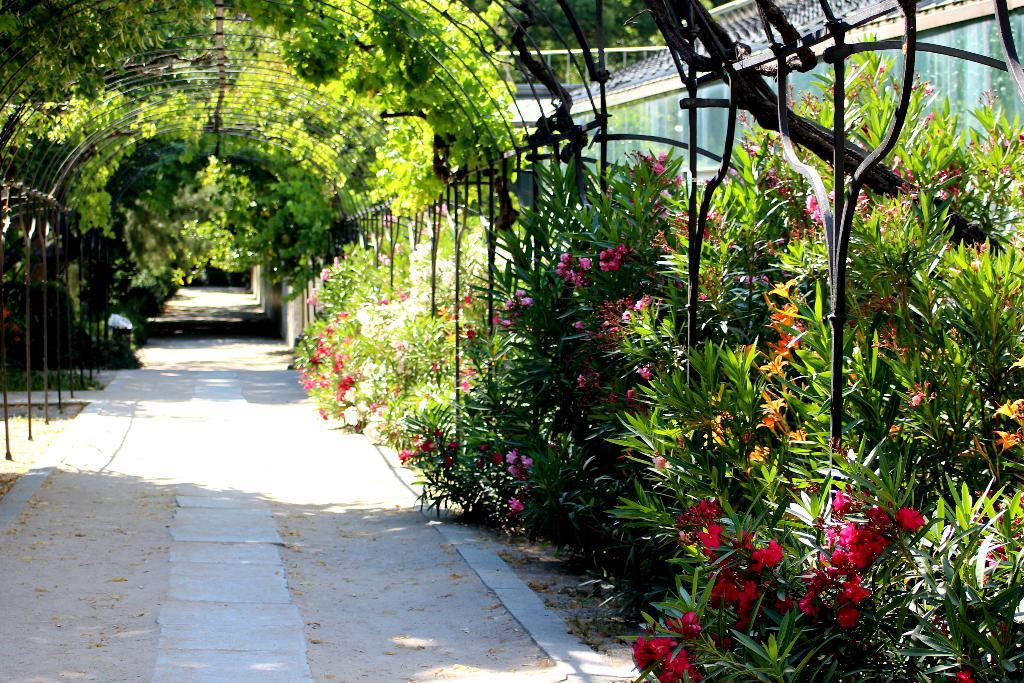What type of vegetation can be seen in the image? There are many plants and trees in the image. Where is the road located in the image? The road is at the bottom of the image. What type of structure is visible to the right of the image? There is a house to the right of the image. What is the level of disgust expressed by the plants in the image? There is no indication of any emotion, including disgust, being expressed by the plants in the image, as plants do not have the ability to express emotions. 